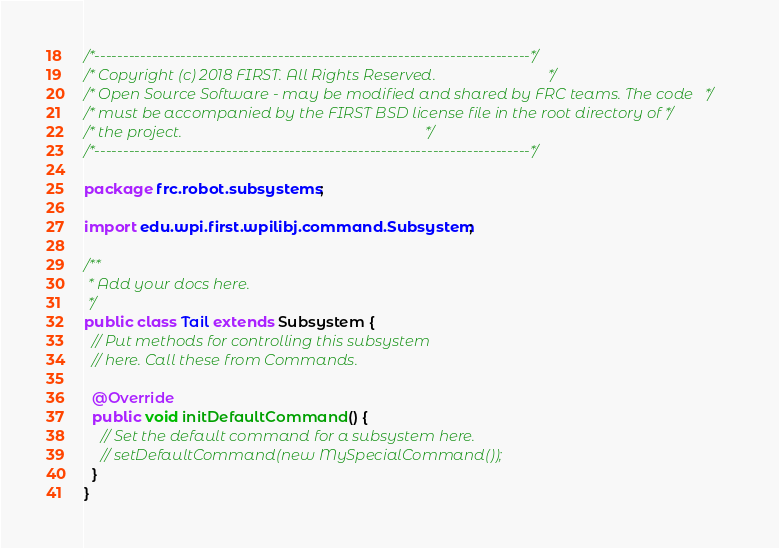Convert code to text. <code><loc_0><loc_0><loc_500><loc_500><_Java_>/*----------------------------------------------------------------------------*/
/* Copyright (c) 2018 FIRST. All Rights Reserved.                             */
/* Open Source Software - may be modified and shared by FRC teams. The code   */
/* must be accompanied by the FIRST BSD license file in the root directory of */
/* the project.                                                               */
/*----------------------------------------------------------------------------*/

package frc.robot.subsystems;

import edu.wpi.first.wpilibj.command.Subsystem;

/**
 * Add your docs here.
 */
public class Tail extends Subsystem {
  // Put methods for controlling this subsystem
  // here. Call these from Commands.

  @Override
  public void initDefaultCommand() {
    // Set the default command for a subsystem here.
    // setDefaultCommand(new MySpecialCommand());
  }
}
</code> 